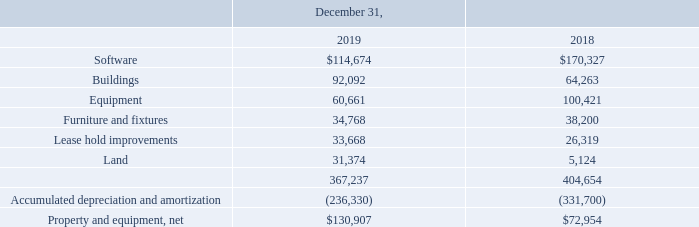(4) Property and Equipment
Property and equipment consist of the following (in thousands):
Depreciation and amortization expense related to property and equipment was $22,538,000, $21,721,000 and $25,787,000 in 2019, 2018 and 2017, respectively.
On November 1, 2019, we completed the purchase of real estate in Chandler, Arizona for approximately $48,000,000 that we intend to use as our global corporate headquarters. The property contains a building and some infrastructure in place that we will complete readying for our use over the next year. We intend to sell our current properties in Tempe, Arizona.
Included within the software, buildings and land values presented above are assets in the process of being readied for use in the amounts of approximately $12,138,000, $27,658,000 and $11,700,000, respectively. Depreciation on these assets will commence, as appropriate, when they are ready for use and placed in service.
How much was Depreciation and amortization expense related to property and equipment  in 2019? $22,538,000. How much was Depreciation and amortization expense related to property and equipment  in 2018? $21,721,000. How much was Depreciation and amortization expense related to property and equipment  in 2017? $25,787,000. What is the change in Software between 2018 and 2019?
Answer scale should be: thousand. 114,674-170,327
Answer: -55653. What is the change in Buildings between 2018 and 2019?
Answer scale should be: thousand. 92,092-64,263
Answer: 27829. What is the average Software for 2018 and 2019?
Answer scale should be: thousand. (114,674+170,327) / 2
Answer: 142500.5. 